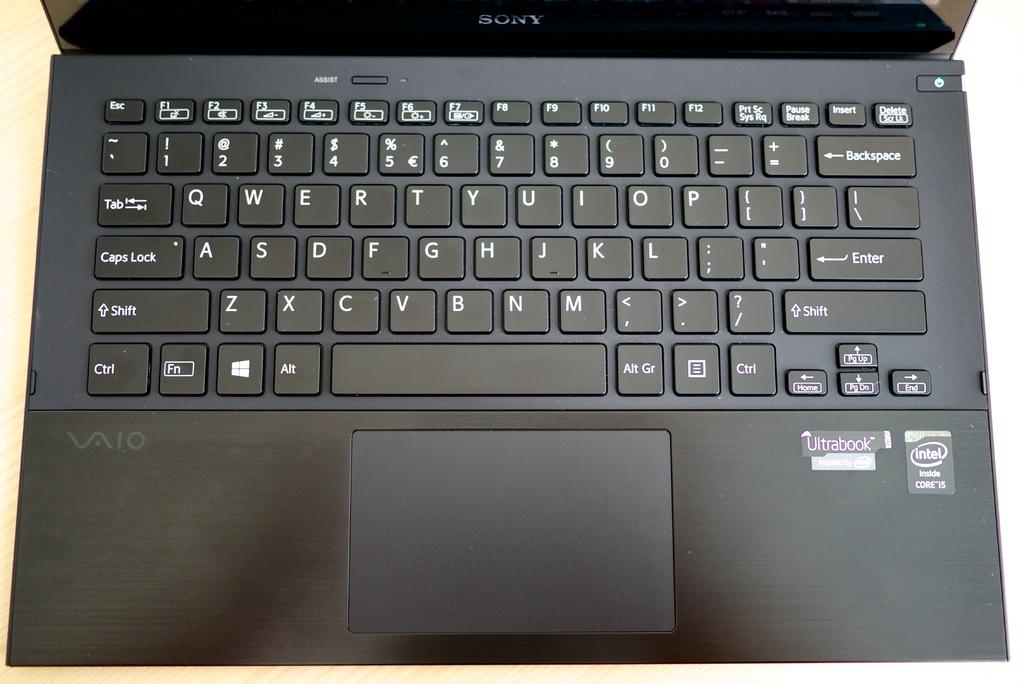What brand cpu is in this laptop?
Your answer should be compact. Intel. What color is this labtop?
Offer a very short reply. Black. 